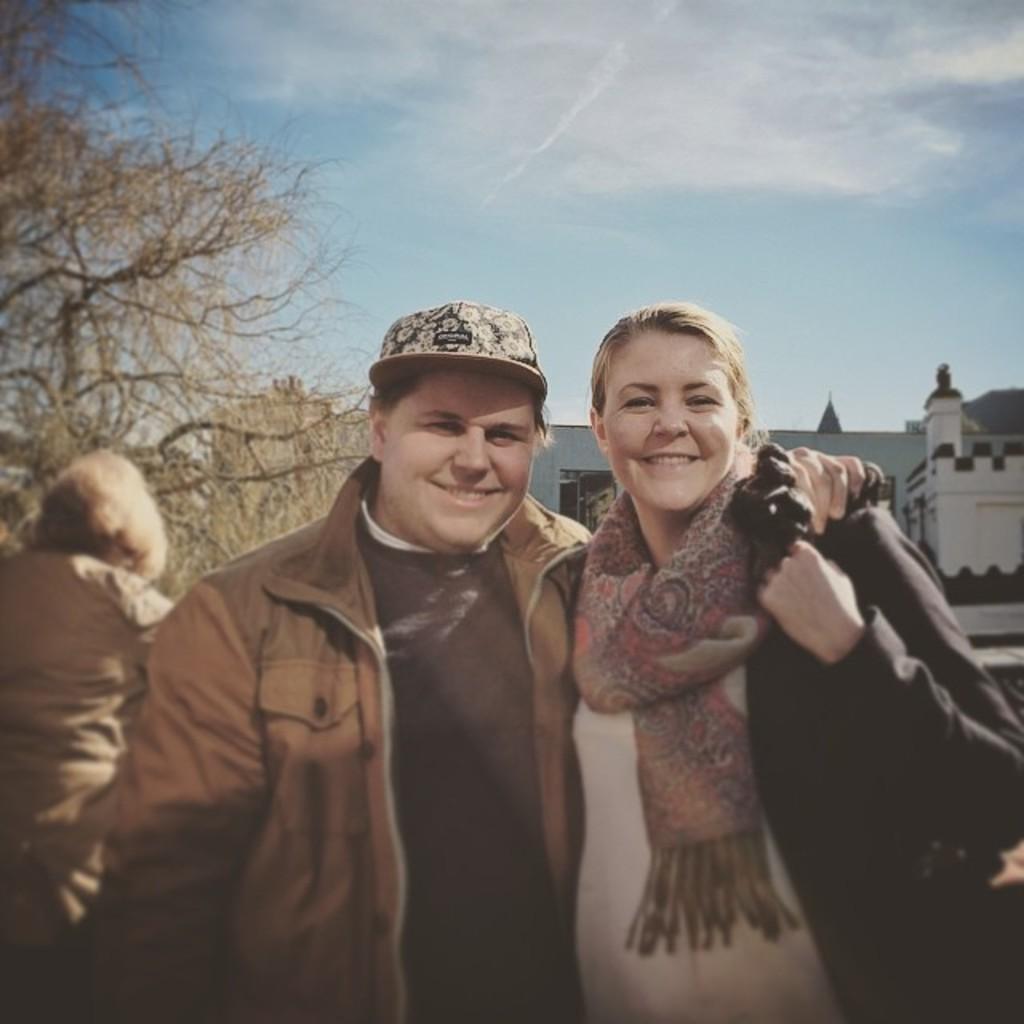In one or two sentences, can you explain what this image depicts? In the center of the image we can see man and woman standing on the road. On the left side of the image there is a tree and a person. In the background there is a building, sky and clouds. 